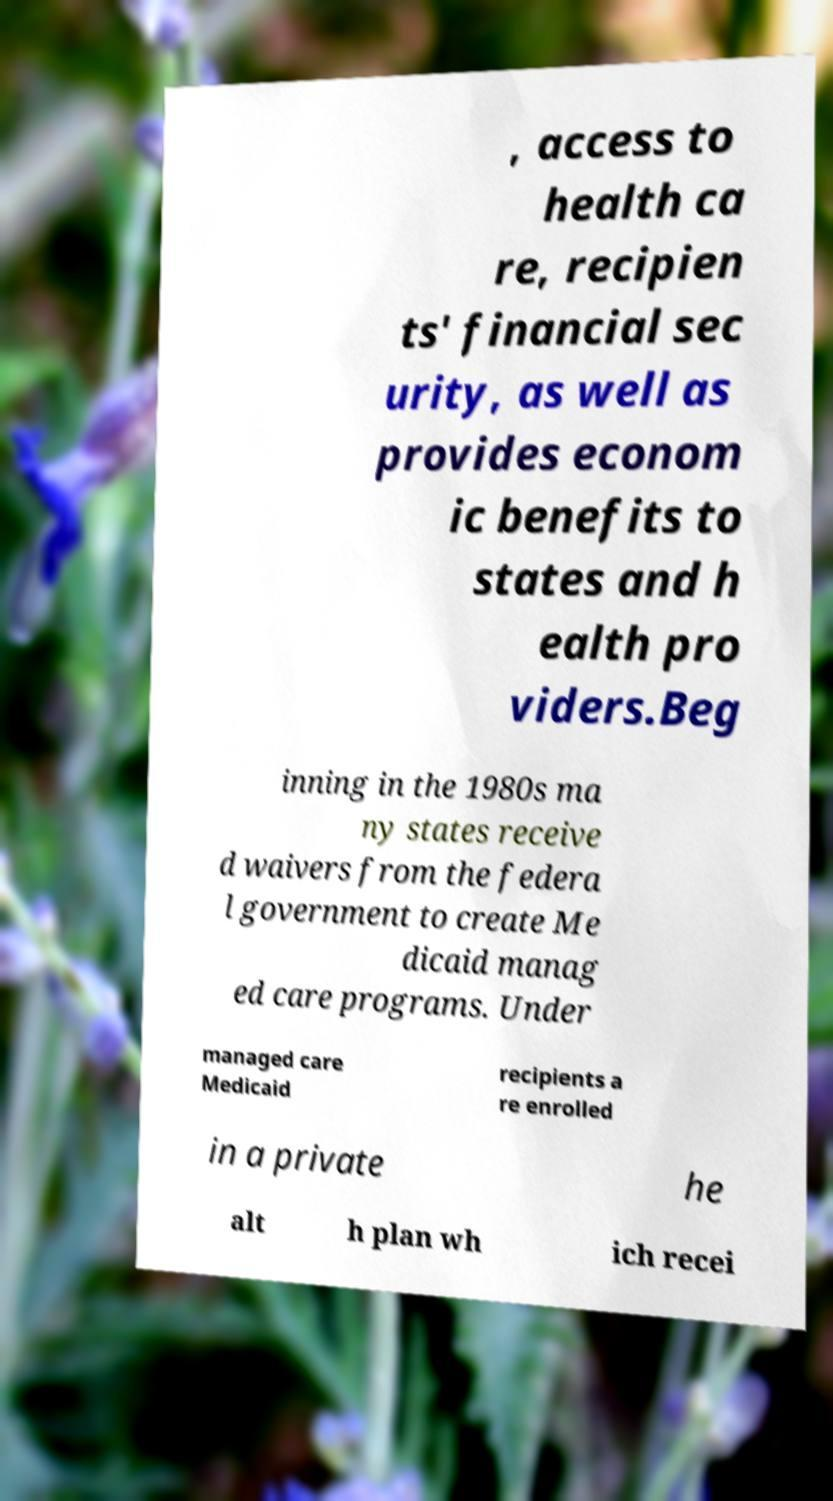Could you extract and type out the text from this image? , access to health ca re, recipien ts' financial sec urity, as well as provides econom ic benefits to states and h ealth pro viders.Beg inning in the 1980s ma ny states receive d waivers from the federa l government to create Me dicaid manag ed care programs. Under managed care Medicaid recipients a re enrolled in a private he alt h plan wh ich recei 